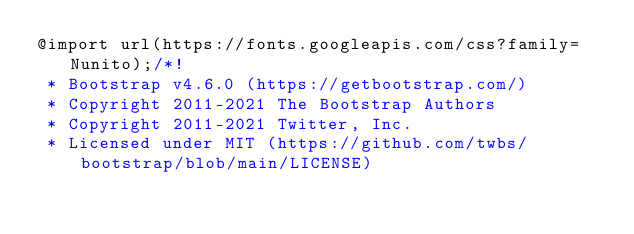Convert code to text. <code><loc_0><loc_0><loc_500><loc_500><_CSS_>@import url(https://fonts.googleapis.com/css?family=Nunito);/*!
 * Bootstrap v4.6.0 (https://getbootstrap.com/)
 * Copyright 2011-2021 The Bootstrap Authors
 * Copyright 2011-2021 Twitter, Inc.
 * Licensed under MIT (https://github.com/twbs/bootstrap/blob/main/LICENSE)</code> 